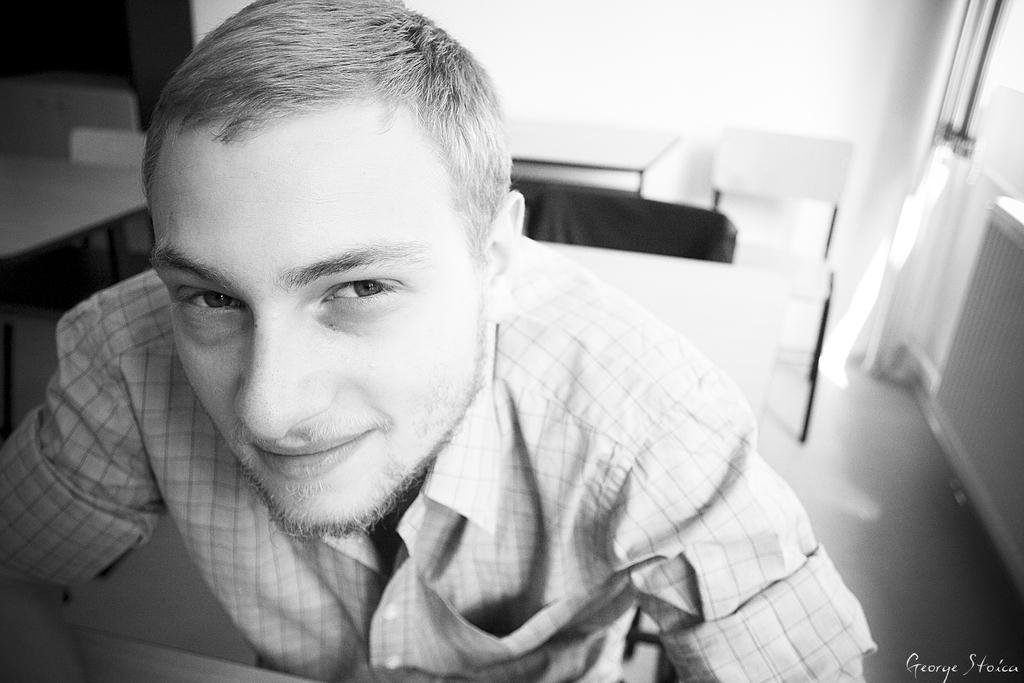How would you summarize this image in a sentence or two? In this image I can see a man and I can see he is wearing shirt. I can also see smile on his face and I can see this image is black and white in colour. Here I can see watermark. 